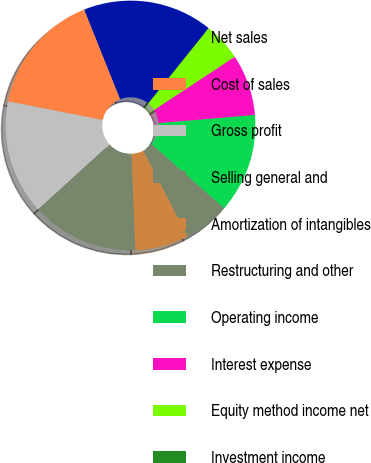Convert chart. <chart><loc_0><loc_0><loc_500><loc_500><pie_chart><fcel>Net sales<fcel>Cost of sales<fcel>Gross profit<fcel>Selling general and<fcel>Amortization of intangibles<fcel>Restructuring and other<fcel>Operating income<fcel>Interest expense<fcel>Equity method income net<fcel>Investment income<nl><fcel>16.83%<fcel>15.84%<fcel>14.85%<fcel>13.86%<fcel>6.93%<fcel>5.94%<fcel>12.87%<fcel>7.92%<fcel>4.95%<fcel>0.0%<nl></chart> 